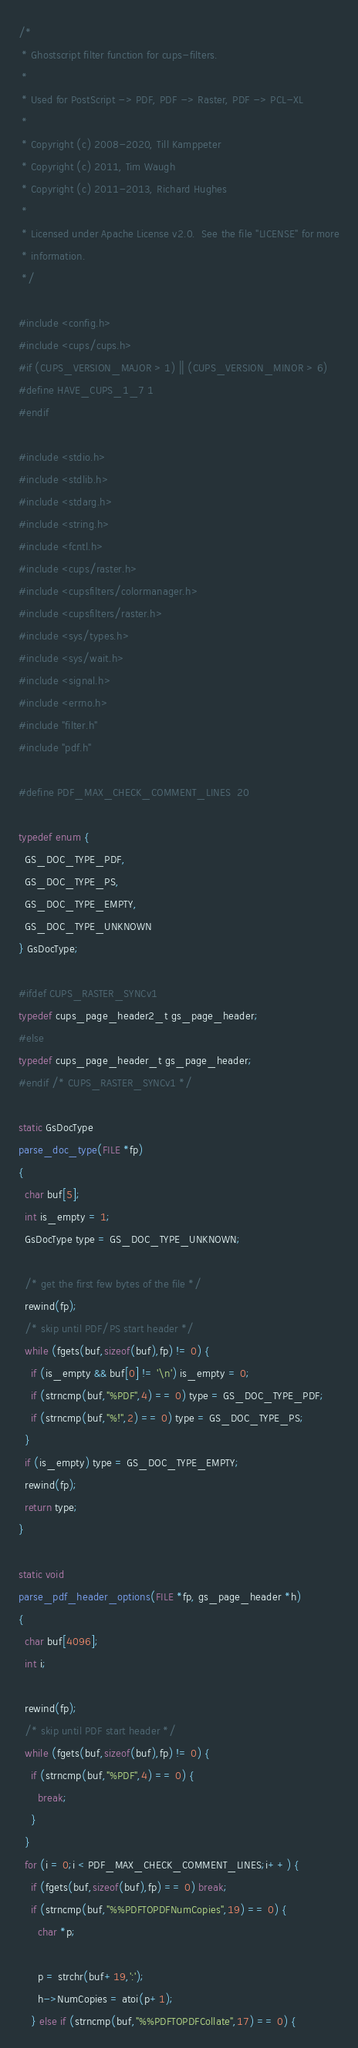Convert code to text. <code><loc_0><loc_0><loc_500><loc_500><_C_>/*
 * Ghostscript filter function for cups-filters.
 *
 * Used for PostScript -> PDF, PDF -> Raster, PDF -> PCL-XL
 *
 * Copyright (c) 2008-2020, Till Kamppeter
 * Copyright (c) 2011, Tim Waugh
 * Copyright (c) 2011-2013, Richard Hughes
 *
 * Licensed under Apache License v2.0.  See the file "LICENSE" for more
 * information.
 */

#include <config.h>
#include <cups/cups.h>
#if (CUPS_VERSION_MAJOR > 1) || (CUPS_VERSION_MINOR > 6)
#define HAVE_CUPS_1_7 1
#endif

#include <stdio.h>
#include <stdlib.h>
#include <stdarg.h>
#include <string.h>
#include <fcntl.h>
#include <cups/raster.h>
#include <cupsfilters/colormanager.h>
#include <cupsfilters/raster.h>
#include <sys/types.h>
#include <sys/wait.h>
#include <signal.h>
#include <errno.h>
#include "filter.h"
#include "pdf.h"

#define PDF_MAX_CHECK_COMMENT_LINES	20

typedef enum {
  GS_DOC_TYPE_PDF,
  GS_DOC_TYPE_PS,
  GS_DOC_TYPE_EMPTY,
  GS_DOC_TYPE_UNKNOWN
} GsDocType;

#ifdef CUPS_RASTER_SYNCv1
typedef cups_page_header2_t gs_page_header;
#else
typedef cups_page_header_t gs_page_header;
#endif /* CUPS_RASTER_SYNCv1 */

static GsDocType
parse_doc_type(FILE *fp)
{
  char buf[5];
  int is_empty = 1;
  GsDocType type = GS_DOC_TYPE_UNKNOWN;

  /* get the first few bytes of the file */
  rewind(fp);
  /* skip until PDF/PS start header */
  while (fgets(buf,sizeof(buf),fp) != 0) {
    if (is_empty && buf[0] != '\n') is_empty = 0;
    if (strncmp(buf,"%PDF",4) == 0) type = GS_DOC_TYPE_PDF;
    if (strncmp(buf,"%!",2) == 0) type = GS_DOC_TYPE_PS;
  }
  if (is_empty) type = GS_DOC_TYPE_EMPTY;
  rewind(fp);
  return type;
}

static void
parse_pdf_header_options(FILE *fp, gs_page_header *h)
{
  char buf[4096];
  int i;

  rewind(fp);
  /* skip until PDF start header */
  while (fgets(buf,sizeof(buf),fp) != 0) {
    if (strncmp(buf,"%PDF",4) == 0) {
      break;
    }
  }
  for (i = 0;i < PDF_MAX_CHECK_COMMENT_LINES;i++) {
    if (fgets(buf,sizeof(buf),fp) == 0) break;
    if (strncmp(buf,"%%PDFTOPDFNumCopies",19) == 0) {
      char *p;

      p = strchr(buf+19,':');
      h->NumCopies = atoi(p+1);
    } else if (strncmp(buf,"%%PDFTOPDFCollate",17) == 0) {</code> 